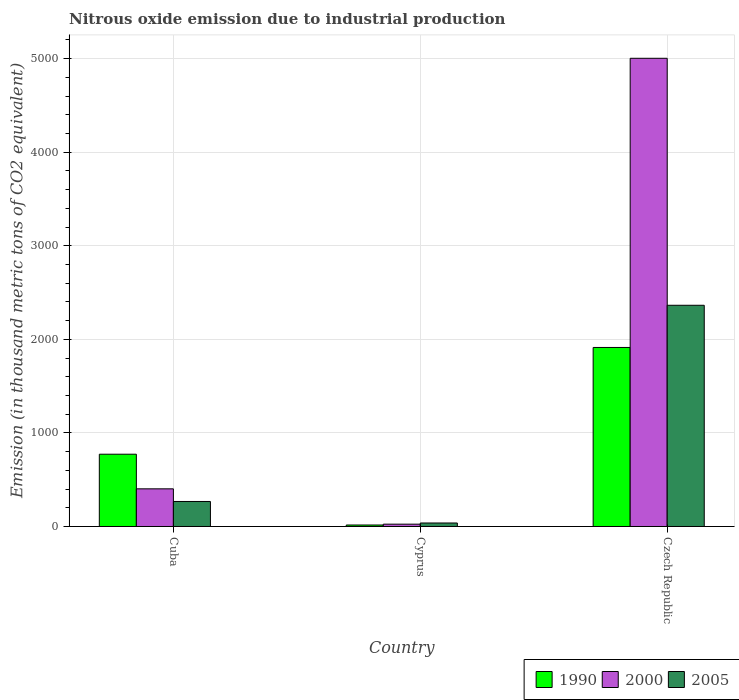How many groups of bars are there?
Offer a very short reply. 3. Are the number of bars per tick equal to the number of legend labels?
Ensure brevity in your answer.  Yes. How many bars are there on the 1st tick from the left?
Provide a succinct answer. 3. What is the label of the 3rd group of bars from the left?
Offer a terse response. Czech Republic. What is the amount of nitrous oxide emitted in 1990 in Czech Republic?
Provide a short and direct response. 1913.6. Across all countries, what is the maximum amount of nitrous oxide emitted in 1990?
Ensure brevity in your answer.  1913.6. Across all countries, what is the minimum amount of nitrous oxide emitted in 2000?
Your response must be concise. 24.8. In which country was the amount of nitrous oxide emitted in 2005 maximum?
Offer a terse response. Czech Republic. In which country was the amount of nitrous oxide emitted in 2005 minimum?
Your answer should be very brief. Cyprus. What is the total amount of nitrous oxide emitted in 1990 in the graph?
Give a very brief answer. 2701.9. What is the difference between the amount of nitrous oxide emitted in 2005 in Cyprus and that in Czech Republic?
Your response must be concise. -2327.2. What is the difference between the amount of nitrous oxide emitted in 2005 in Cyprus and the amount of nitrous oxide emitted in 2000 in Cuba?
Your response must be concise. -365.2. What is the average amount of nitrous oxide emitted in 2005 per country?
Give a very brief answer. 889.7. What is the difference between the amount of nitrous oxide emitted of/in 2005 and amount of nitrous oxide emitted of/in 1990 in Czech Republic?
Offer a very short reply. 450.9. What is the ratio of the amount of nitrous oxide emitted in 2000 in Cuba to that in Cyprus?
Ensure brevity in your answer.  16.23. Is the amount of nitrous oxide emitted in 2005 in Cyprus less than that in Czech Republic?
Offer a very short reply. Yes. Is the difference between the amount of nitrous oxide emitted in 2005 in Cyprus and Czech Republic greater than the difference between the amount of nitrous oxide emitted in 1990 in Cyprus and Czech Republic?
Make the answer very short. No. What is the difference between the highest and the second highest amount of nitrous oxide emitted in 2000?
Keep it short and to the point. -377.7. What is the difference between the highest and the lowest amount of nitrous oxide emitted in 2005?
Offer a very short reply. 2327.2. In how many countries, is the amount of nitrous oxide emitted in 1990 greater than the average amount of nitrous oxide emitted in 1990 taken over all countries?
Keep it short and to the point. 1. What does the 1st bar from the left in Cuba represents?
Provide a succinct answer. 1990. What does the 1st bar from the right in Cyprus represents?
Keep it short and to the point. 2005. Is it the case that in every country, the sum of the amount of nitrous oxide emitted in 2005 and amount of nitrous oxide emitted in 1990 is greater than the amount of nitrous oxide emitted in 2000?
Your answer should be very brief. No. How many countries are there in the graph?
Give a very brief answer. 3. Does the graph contain grids?
Keep it short and to the point. Yes. Where does the legend appear in the graph?
Give a very brief answer. Bottom right. How many legend labels are there?
Your response must be concise. 3. How are the legend labels stacked?
Give a very brief answer. Horizontal. What is the title of the graph?
Provide a short and direct response. Nitrous oxide emission due to industrial production. Does "1974" appear as one of the legend labels in the graph?
Give a very brief answer. No. What is the label or title of the X-axis?
Your answer should be compact. Country. What is the label or title of the Y-axis?
Keep it short and to the point. Emission (in thousand metric tons of CO2 equivalent). What is the Emission (in thousand metric tons of CO2 equivalent) of 1990 in Cuba?
Give a very brief answer. 772.5. What is the Emission (in thousand metric tons of CO2 equivalent) of 2000 in Cuba?
Give a very brief answer. 402.5. What is the Emission (in thousand metric tons of CO2 equivalent) of 2005 in Cuba?
Provide a succinct answer. 267.3. What is the Emission (in thousand metric tons of CO2 equivalent) of 2000 in Cyprus?
Your answer should be very brief. 24.8. What is the Emission (in thousand metric tons of CO2 equivalent) of 2005 in Cyprus?
Ensure brevity in your answer.  37.3. What is the Emission (in thousand metric tons of CO2 equivalent) of 1990 in Czech Republic?
Offer a very short reply. 1913.6. What is the Emission (in thousand metric tons of CO2 equivalent) of 2000 in Czech Republic?
Your answer should be very brief. 5004.5. What is the Emission (in thousand metric tons of CO2 equivalent) in 2005 in Czech Republic?
Your answer should be very brief. 2364.5. Across all countries, what is the maximum Emission (in thousand metric tons of CO2 equivalent) of 1990?
Offer a very short reply. 1913.6. Across all countries, what is the maximum Emission (in thousand metric tons of CO2 equivalent) in 2000?
Keep it short and to the point. 5004.5. Across all countries, what is the maximum Emission (in thousand metric tons of CO2 equivalent) of 2005?
Give a very brief answer. 2364.5. Across all countries, what is the minimum Emission (in thousand metric tons of CO2 equivalent) of 1990?
Give a very brief answer. 15.8. Across all countries, what is the minimum Emission (in thousand metric tons of CO2 equivalent) in 2000?
Your answer should be very brief. 24.8. Across all countries, what is the minimum Emission (in thousand metric tons of CO2 equivalent) in 2005?
Make the answer very short. 37.3. What is the total Emission (in thousand metric tons of CO2 equivalent) of 1990 in the graph?
Your answer should be very brief. 2701.9. What is the total Emission (in thousand metric tons of CO2 equivalent) in 2000 in the graph?
Ensure brevity in your answer.  5431.8. What is the total Emission (in thousand metric tons of CO2 equivalent) in 2005 in the graph?
Offer a very short reply. 2669.1. What is the difference between the Emission (in thousand metric tons of CO2 equivalent) in 1990 in Cuba and that in Cyprus?
Your response must be concise. 756.7. What is the difference between the Emission (in thousand metric tons of CO2 equivalent) of 2000 in Cuba and that in Cyprus?
Provide a short and direct response. 377.7. What is the difference between the Emission (in thousand metric tons of CO2 equivalent) in 2005 in Cuba and that in Cyprus?
Your answer should be very brief. 230. What is the difference between the Emission (in thousand metric tons of CO2 equivalent) of 1990 in Cuba and that in Czech Republic?
Ensure brevity in your answer.  -1141.1. What is the difference between the Emission (in thousand metric tons of CO2 equivalent) of 2000 in Cuba and that in Czech Republic?
Provide a succinct answer. -4602. What is the difference between the Emission (in thousand metric tons of CO2 equivalent) of 2005 in Cuba and that in Czech Republic?
Offer a terse response. -2097.2. What is the difference between the Emission (in thousand metric tons of CO2 equivalent) of 1990 in Cyprus and that in Czech Republic?
Keep it short and to the point. -1897.8. What is the difference between the Emission (in thousand metric tons of CO2 equivalent) in 2000 in Cyprus and that in Czech Republic?
Ensure brevity in your answer.  -4979.7. What is the difference between the Emission (in thousand metric tons of CO2 equivalent) of 2005 in Cyprus and that in Czech Republic?
Keep it short and to the point. -2327.2. What is the difference between the Emission (in thousand metric tons of CO2 equivalent) in 1990 in Cuba and the Emission (in thousand metric tons of CO2 equivalent) in 2000 in Cyprus?
Ensure brevity in your answer.  747.7. What is the difference between the Emission (in thousand metric tons of CO2 equivalent) of 1990 in Cuba and the Emission (in thousand metric tons of CO2 equivalent) of 2005 in Cyprus?
Keep it short and to the point. 735.2. What is the difference between the Emission (in thousand metric tons of CO2 equivalent) in 2000 in Cuba and the Emission (in thousand metric tons of CO2 equivalent) in 2005 in Cyprus?
Keep it short and to the point. 365.2. What is the difference between the Emission (in thousand metric tons of CO2 equivalent) in 1990 in Cuba and the Emission (in thousand metric tons of CO2 equivalent) in 2000 in Czech Republic?
Keep it short and to the point. -4232. What is the difference between the Emission (in thousand metric tons of CO2 equivalent) of 1990 in Cuba and the Emission (in thousand metric tons of CO2 equivalent) of 2005 in Czech Republic?
Offer a terse response. -1592. What is the difference between the Emission (in thousand metric tons of CO2 equivalent) in 2000 in Cuba and the Emission (in thousand metric tons of CO2 equivalent) in 2005 in Czech Republic?
Offer a very short reply. -1962. What is the difference between the Emission (in thousand metric tons of CO2 equivalent) in 1990 in Cyprus and the Emission (in thousand metric tons of CO2 equivalent) in 2000 in Czech Republic?
Ensure brevity in your answer.  -4988.7. What is the difference between the Emission (in thousand metric tons of CO2 equivalent) of 1990 in Cyprus and the Emission (in thousand metric tons of CO2 equivalent) of 2005 in Czech Republic?
Ensure brevity in your answer.  -2348.7. What is the difference between the Emission (in thousand metric tons of CO2 equivalent) of 2000 in Cyprus and the Emission (in thousand metric tons of CO2 equivalent) of 2005 in Czech Republic?
Provide a short and direct response. -2339.7. What is the average Emission (in thousand metric tons of CO2 equivalent) in 1990 per country?
Give a very brief answer. 900.63. What is the average Emission (in thousand metric tons of CO2 equivalent) in 2000 per country?
Your answer should be very brief. 1810.6. What is the average Emission (in thousand metric tons of CO2 equivalent) of 2005 per country?
Give a very brief answer. 889.7. What is the difference between the Emission (in thousand metric tons of CO2 equivalent) of 1990 and Emission (in thousand metric tons of CO2 equivalent) of 2000 in Cuba?
Make the answer very short. 370. What is the difference between the Emission (in thousand metric tons of CO2 equivalent) of 1990 and Emission (in thousand metric tons of CO2 equivalent) of 2005 in Cuba?
Keep it short and to the point. 505.2. What is the difference between the Emission (in thousand metric tons of CO2 equivalent) in 2000 and Emission (in thousand metric tons of CO2 equivalent) in 2005 in Cuba?
Your response must be concise. 135.2. What is the difference between the Emission (in thousand metric tons of CO2 equivalent) of 1990 and Emission (in thousand metric tons of CO2 equivalent) of 2005 in Cyprus?
Give a very brief answer. -21.5. What is the difference between the Emission (in thousand metric tons of CO2 equivalent) in 1990 and Emission (in thousand metric tons of CO2 equivalent) in 2000 in Czech Republic?
Ensure brevity in your answer.  -3090.9. What is the difference between the Emission (in thousand metric tons of CO2 equivalent) in 1990 and Emission (in thousand metric tons of CO2 equivalent) in 2005 in Czech Republic?
Offer a very short reply. -450.9. What is the difference between the Emission (in thousand metric tons of CO2 equivalent) of 2000 and Emission (in thousand metric tons of CO2 equivalent) of 2005 in Czech Republic?
Provide a succinct answer. 2640. What is the ratio of the Emission (in thousand metric tons of CO2 equivalent) in 1990 in Cuba to that in Cyprus?
Provide a succinct answer. 48.89. What is the ratio of the Emission (in thousand metric tons of CO2 equivalent) of 2000 in Cuba to that in Cyprus?
Ensure brevity in your answer.  16.23. What is the ratio of the Emission (in thousand metric tons of CO2 equivalent) of 2005 in Cuba to that in Cyprus?
Your answer should be very brief. 7.17. What is the ratio of the Emission (in thousand metric tons of CO2 equivalent) in 1990 in Cuba to that in Czech Republic?
Your answer should be very brief. 0.4. What is the ratio of the Emission (in thousand metric tons of CO2 equivalent) of 2000 in Cuba to that in Czech Republic?
Your answer should be compact. 0.08. What is the ratio of the Emission (in thousand metric tons of CO2 equivalent) in 2005 in Cuba to that in Czech Republic?
Your answer should be compact. 0.11. What is the ratio of the Emission (in thousand metric tons of CO2 equivalent) in 1990 in Cyprus to that in Czech Republic?
Make the answer very short. 0.01. What is the ratio of the Emission (in thousand metric tons of CO2 equivalent) of 2000 in Cyprus to that in Czech Republic?
Offer a terse response. 0.01. What is the ratio of the Emission (in thousand metric tons of CO2 equivalent) of 2005 in Cyprus to that in Czech Republic?
Your answer should be compact. 0.02. What is the difference between the highest and the second highest Emission (in thousand metric tons of CO2 equivalent) in 1990?
Keep it short and to the point. 1141.1. What is the difference between the highest and the second highest Emission (in thousand metric tons of CO2 equivalent) in 2000?
Give a very brief answer. 4602. What is the difference between the highest and the second highest Emission (in thousand metric tons of CO2 equivalent) in 2005?
Your answer should be compact. 2097.2. What is the difference between the highest and the lowest Emission (in thousand metric tons of CO2 equivalent) in 1990?
Keep it short and to the point. 1897.8. What is the difference between the highest and the lowest Emission (in thousand metric tons of CO2 equivalent) of 2000?
Your response must be concise. 4979.7. What is the difference between the highest and the lowest Emission (in thousand metric tons of CO2 equivalent) of 2005?
Your answer should be compact. 2327.2. 